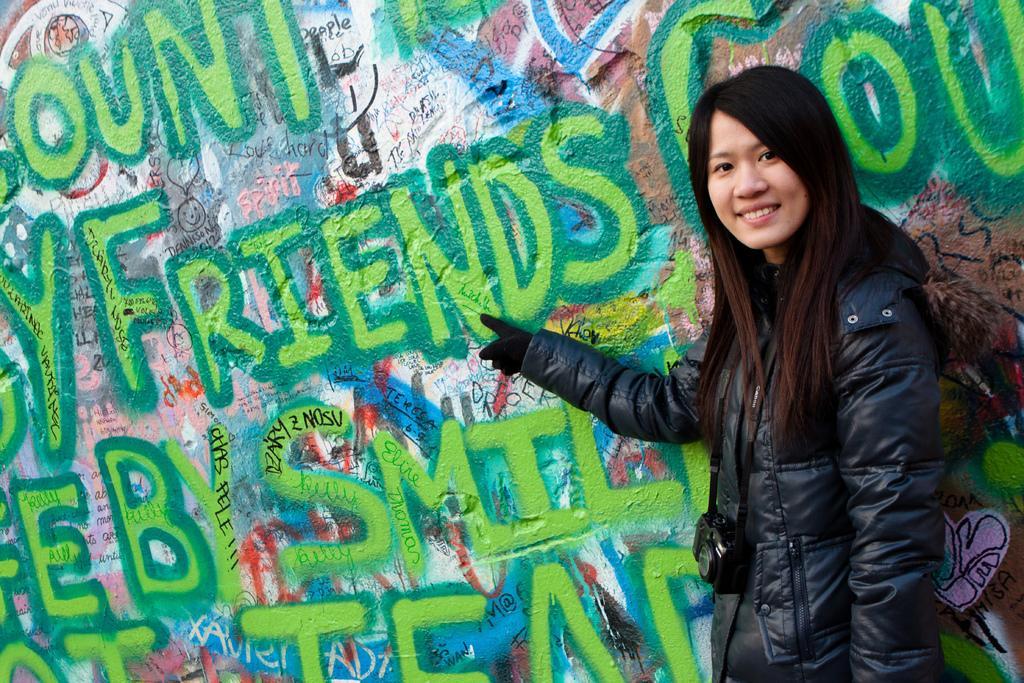Please provide a concise description of this image. In this image I can see the person standing and wearing the jacket and camera. To the side of the person I can see the wall. On the wall I can see many names. 